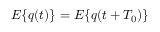<formula> <loc_0><loc_0><loc_500><loc_500>E \{ q ( t ) \} = E \{ q ( t + T _ { 0 } ) \}</formula> 